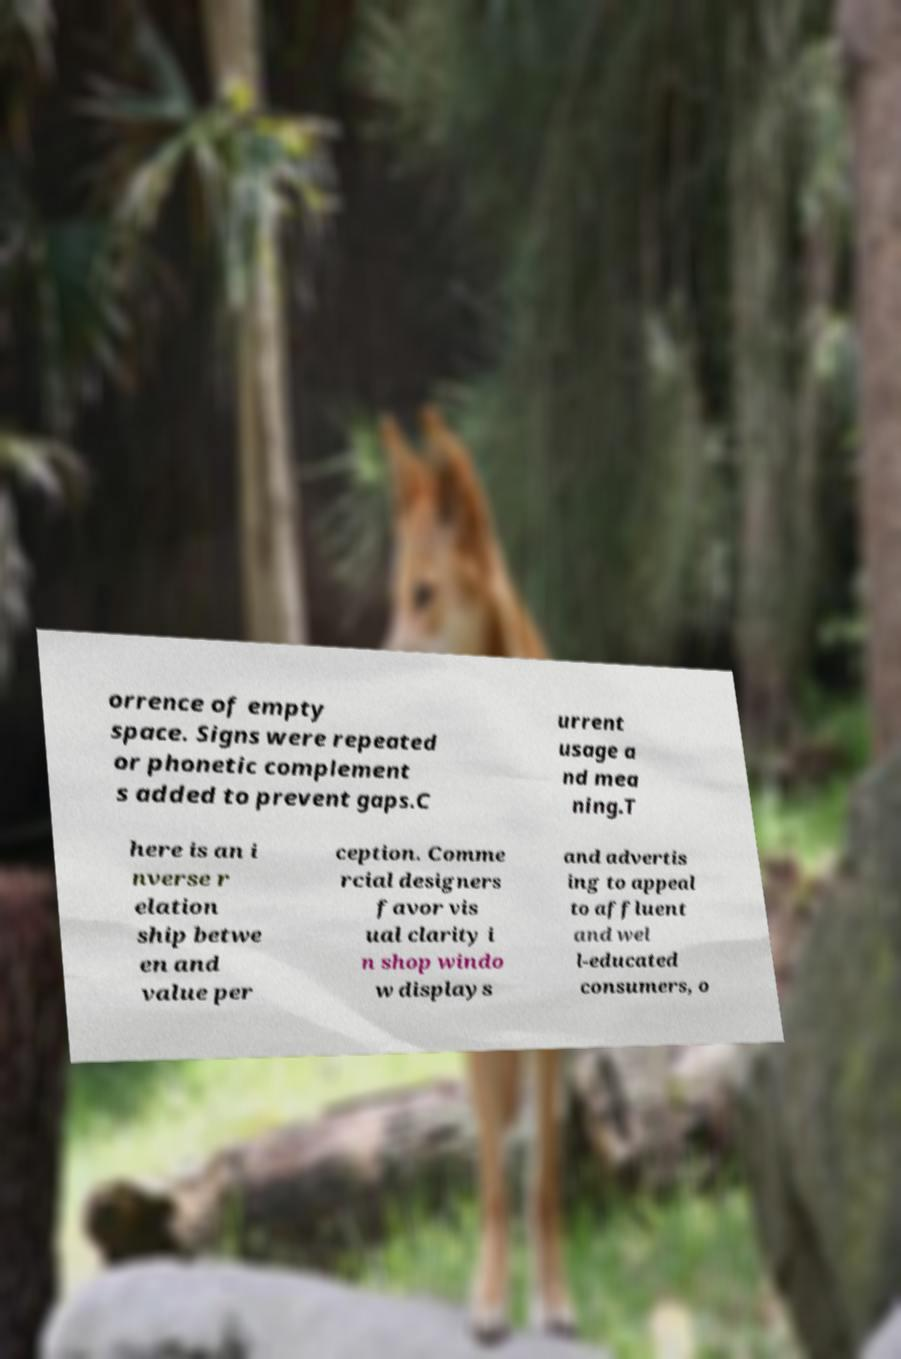Please read and relay the text visible in this image. What does it say? orrence of empty space. Signs were repeated or phonetic complement s added to prevent gaps.C urrent usage a nd mea ning.T here is an i nverse r elation ship betwe en and value per ception. Comme rcial designers favor vis ual clarity i n shop windo w displays and advertis ing to appeal to affluent and wel l-educated consumers, o 